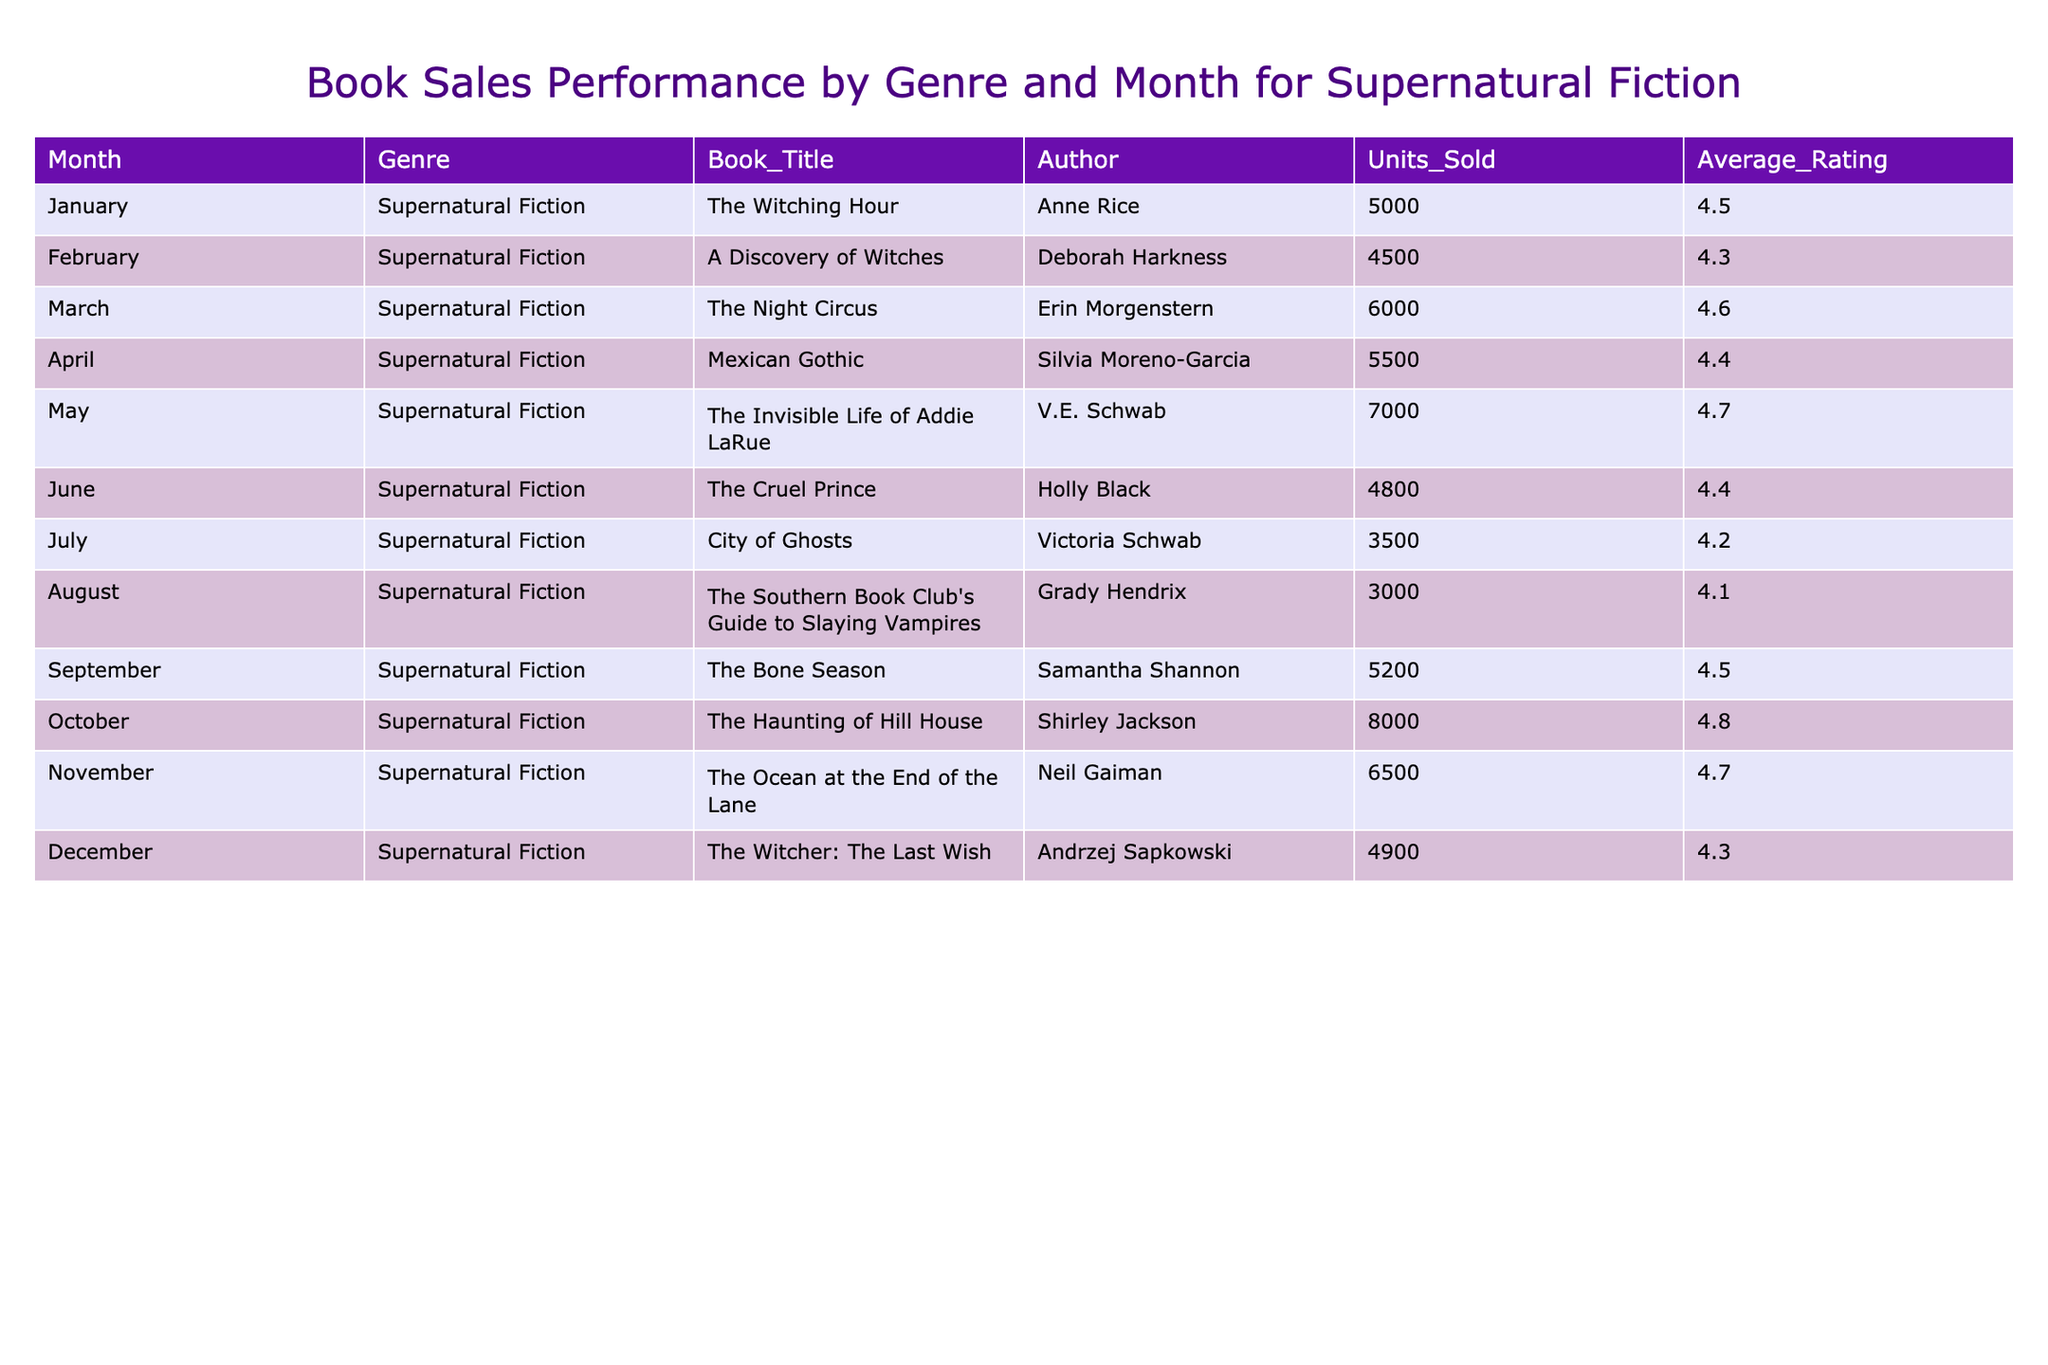What is the title of the book with the highest units sold in October? In the table, we locate the month of October and check the corresponding units sold. The book "The Haunting of Hill House" has the highest units sold, totaling 8000.
Answer: The Haunting of Hill House Which book had the lowest average rating among all titles listed? By reviewing the average ratings for each title, we find that "The Southern Book Club's Guide to Slaying Vampires" has the lowest rating at 4.1.
Answer: The Southern Book Club's Guide to Slaying Vampires What is the total number of units sold for books in the first half of the year (January to June)? We sum up the units sold from January to June: 5000 + 4500 + 6000 + 5500 + 7000 + 4800 = 33900.
Answer: 33900 How many books had units sold greater than 5000? By examining each row, we count the books with units sold greater than 5000, which are "The Witching Hour," "The Night Circus," "Mexican Gothic," "The Invisible Life of Addie LaRue," "The Haunting of Hill House," and "The Ocean at the End of the Lane," totaling 6 books.
Answer: 6 What is the average rating for books published from May to October? We first extract the average ratings for May (4.7), June (4.4), July (4.2), August (4.1), September (4.5), October (4.8). The average rating is (4.7 + 4.4 + 4.2 + 4.1 + 4.5 + 4.8) / 6 = 4.45.
Answer: 4.45 Which month had the second-highest units sold for supernatural fiction? We need to analyze the units sold for each month: October (8000), May (7000), November (6500), March (6000), April (5500), which shows that May had the second-highest units sold with 7000.
Answer: May Did any book have both units sold below 4000 and an average rating above 4.5? Checking the data, "City of Ghosts" has units sold (3500) and an average rating (4.2), and "The Southern Book Club's Guide to Slaying Vampires" has units sold (3000) with an average rating of 4.1, indicating no such book exists.
Answer: No What is the difference in units sold between the highest and lowest selling books? The highest selling book is "The Haunting of Hill House" with 8000 units, and the lowest is "The Southern Book Club's Guide to Slaying Vampires" with 3000 units. The difference is 8000 - 3000 = 5000.
Answer: 5000 